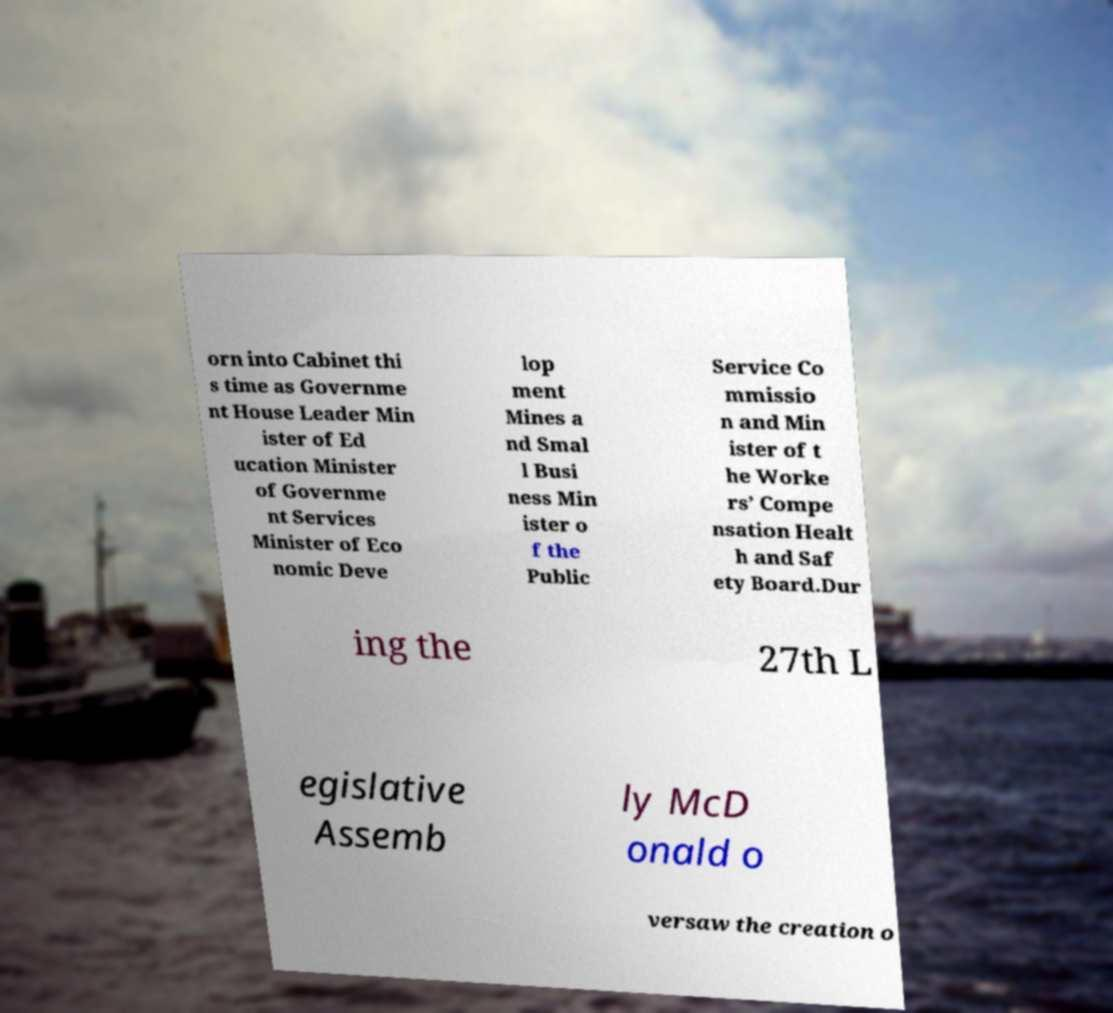Please identify and transcribe the text found in this image. orn into Cabinet thi s time as Governme nt House Leader Min ister of Ed ucation Minister of Governme nt Services Minister of Eco nomic Deve lop ment Mines a nd Smal l Busi ness Min ister o f the Public Service Co mmissio n and Min ister of t he Worke rs’ Compe nsation Healt h and Saf ety Board.Dur ing the 27th L egislative Assemb ly McD onald o versaw the creation o 